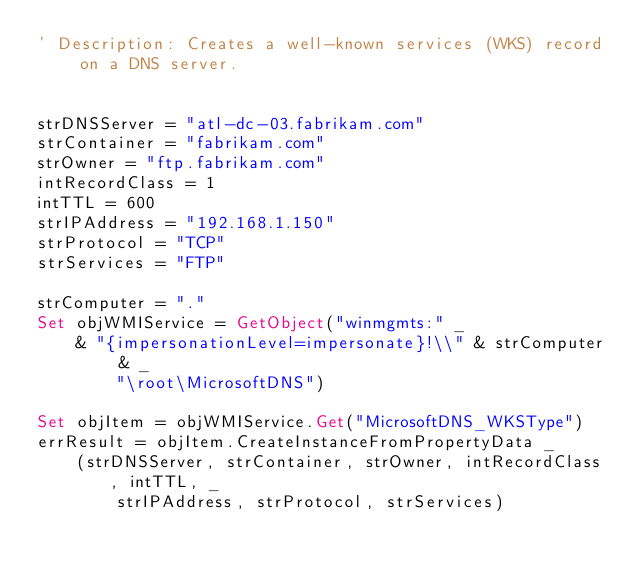<code> <loc_0><loc_0><loc_500><loc_500><_VisualBasic_>' Description: Creates a well-known services (WKS) record on a DNS server.


strDNSServer = "atl-dc-03.fabrikam.com"
strContainer = "fabrikam.com"
strOwner = "ftp.fabrikam.com"
intRecordClass = 1
intTTL = 600 
strIPAddress = "192.168.1.150"
strProtocol = "TCP"
strServices = "FTP"
 
strComputer = "."
Set objWMIService = GetObject("winmgmts:" _
    & "{impersonationLevel=impersonate}!\\" & strComputer & _
        "\root\MicrosoftDNS")

Set objItem = objWMIService.Get("MicrosoftDNS_WKSType")
errResult = objItem.CreateInstanceFromPropertyData _
    (strDNSServer, strContainer, strOwner, intRecordClass, intTTL, _
        strIPAddress, strProtocol, strServices)

</code> 